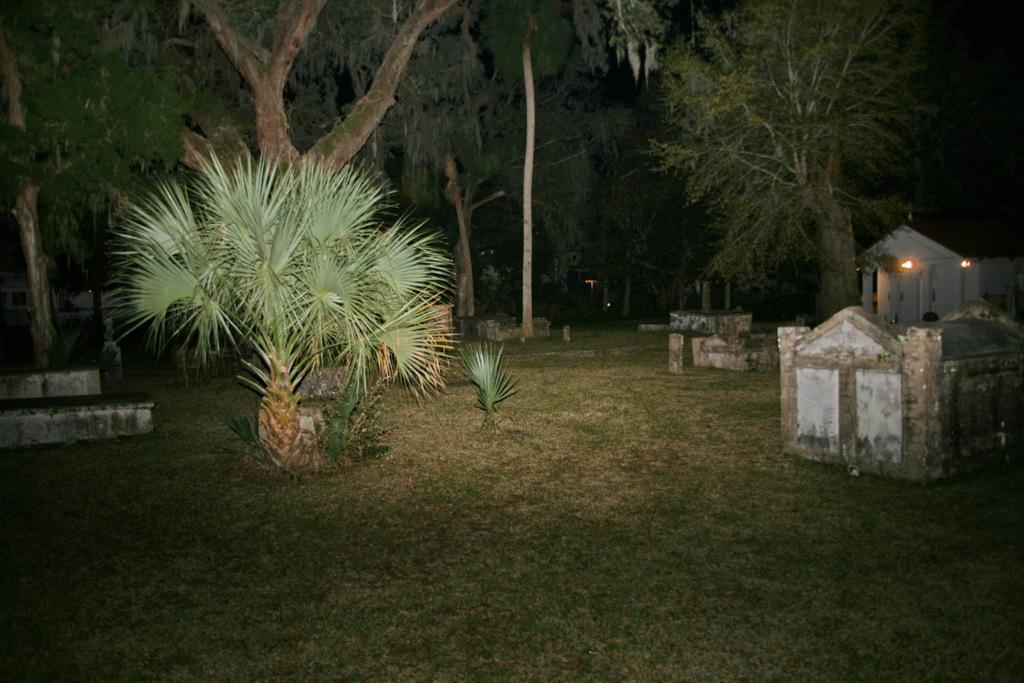What type of vegetation is present on the grassland in the image? There are trees on the grassland in the image. What structure can be seen on the right side of the image? There is a house with lights attached to the wall on the right side of the image. What else can be found on the grassland besides trees? There are constructions on the grassland. How many lips can be seen on the trees in the image? There are no lips present on the trees in the image. Is the wilderness depicted in the image suitable for sleeping? The provided facts do not mention any information about the suitability of the wilderness for sleeping. 